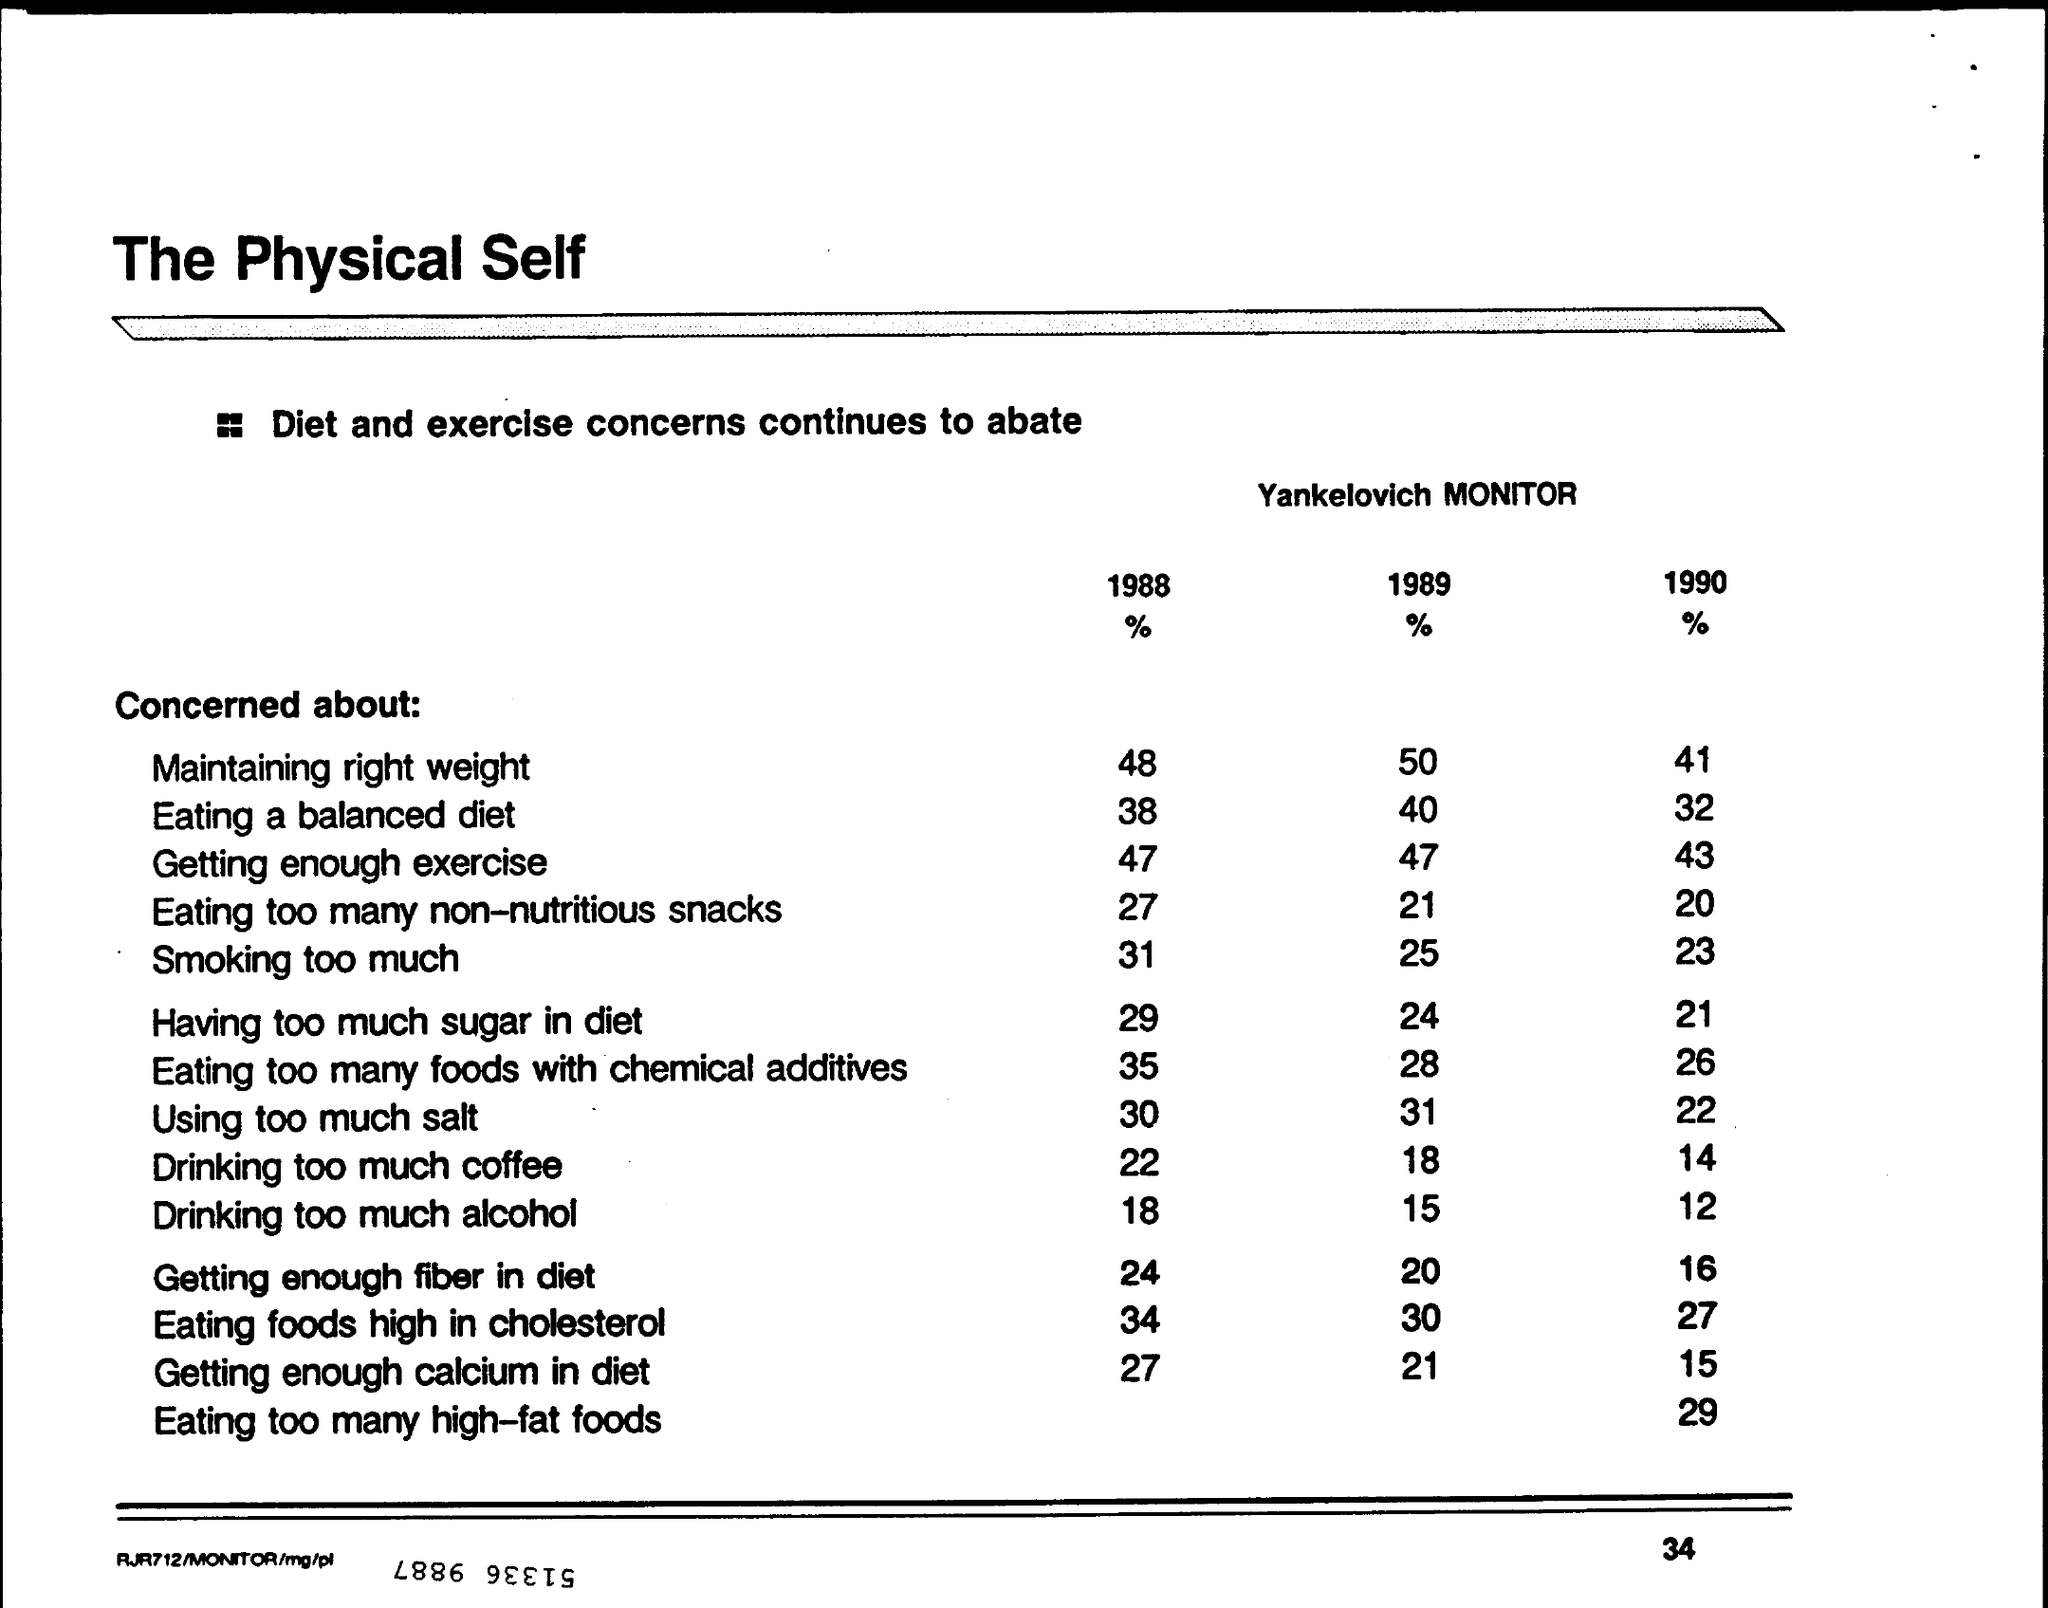What % are Concerned about "Maintaining right weight" for 1988?
Your response must be concise. 48. What % are Concerned about "Maintaining right weight" for 1989?
Your response must be concise. 50. What % are Concerned about "Maintaining right weight" for 1990?
Your answer should be very brief. 41. What % are Concerned about "Eating a balanced diet" for 1988?
Offer a very short reply. 38. What % are Concerned about "Eating a balanced diet" for 1989?
Offer a terse response. 40. What % are Concerned about "Eating a balanced diet" for 1990?
Provide a succinct answer. 32. What % are Concerned about "Using too much salt" for 1988?
Your answer should be very brief. 30. What % are Concerned about "Using too much salt" for 1989?
Offer a very short reply. 31. What % are Concerned about "Using too much salt" for 1990?
Keep it short and to the point. 22. What % are Concerned about "Drinking too much alcohol" for 1988?
Offer a very short reply. 18. What % are Concerned about "Drinking too much alcohol" for 1989?
Your response must be concise. 15. 